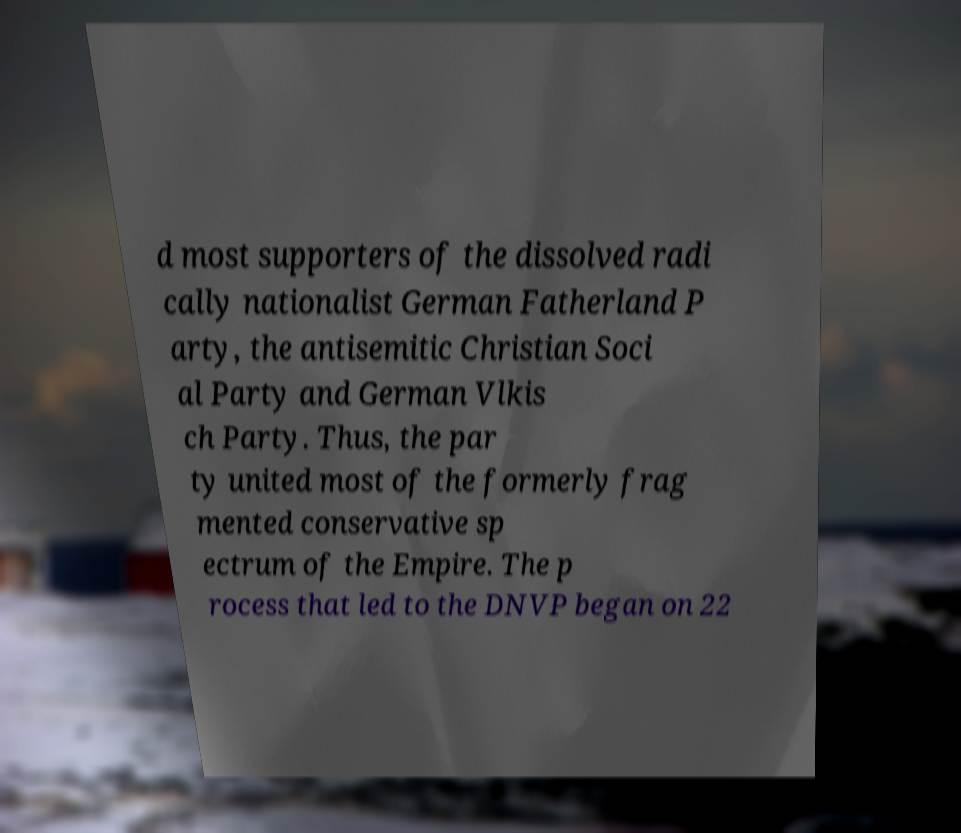Can you accurately transcribe the text from the provided image for me? d most supporters of the dissolved radi cally nationalist German Fatherland P arty, the antisemitic Christian Soci al Party and German Vlkis ch Party. Thus, the par ty united most of the formerly frag mented conservative sp ectrum of the Empire. The p rocess that led to the DNVP began on 22 